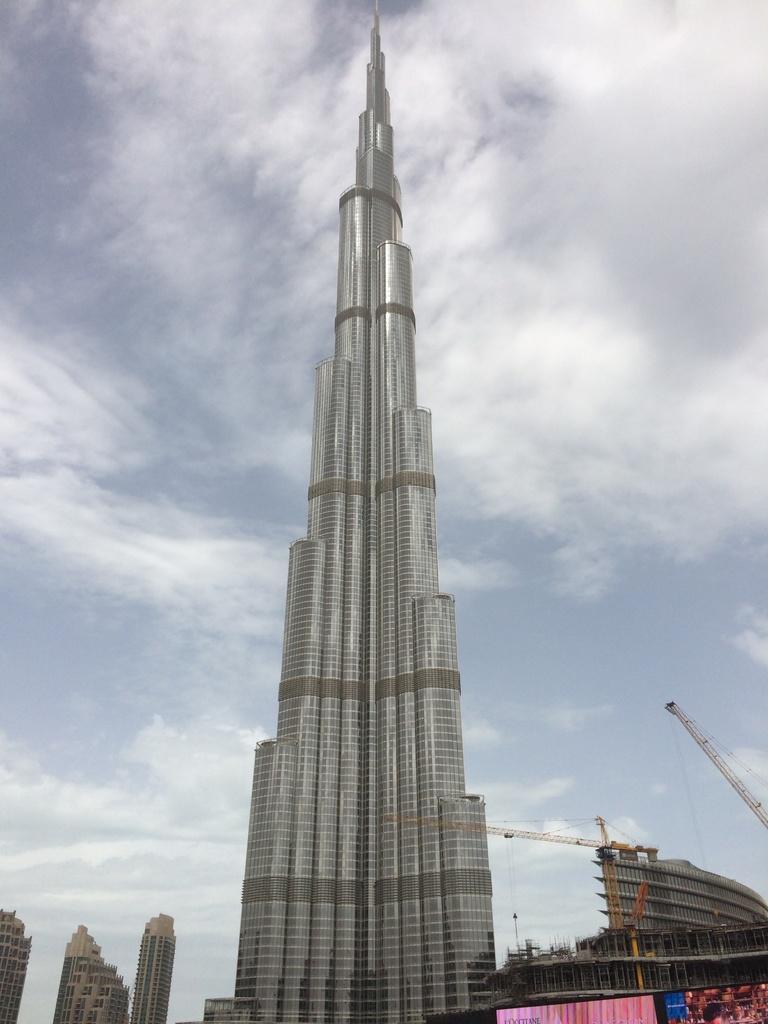In one or two sentences, can you explain what this image depicts? In the image in the center we can see buildings,screen and tower. In the background we can see the sky and clouds. 